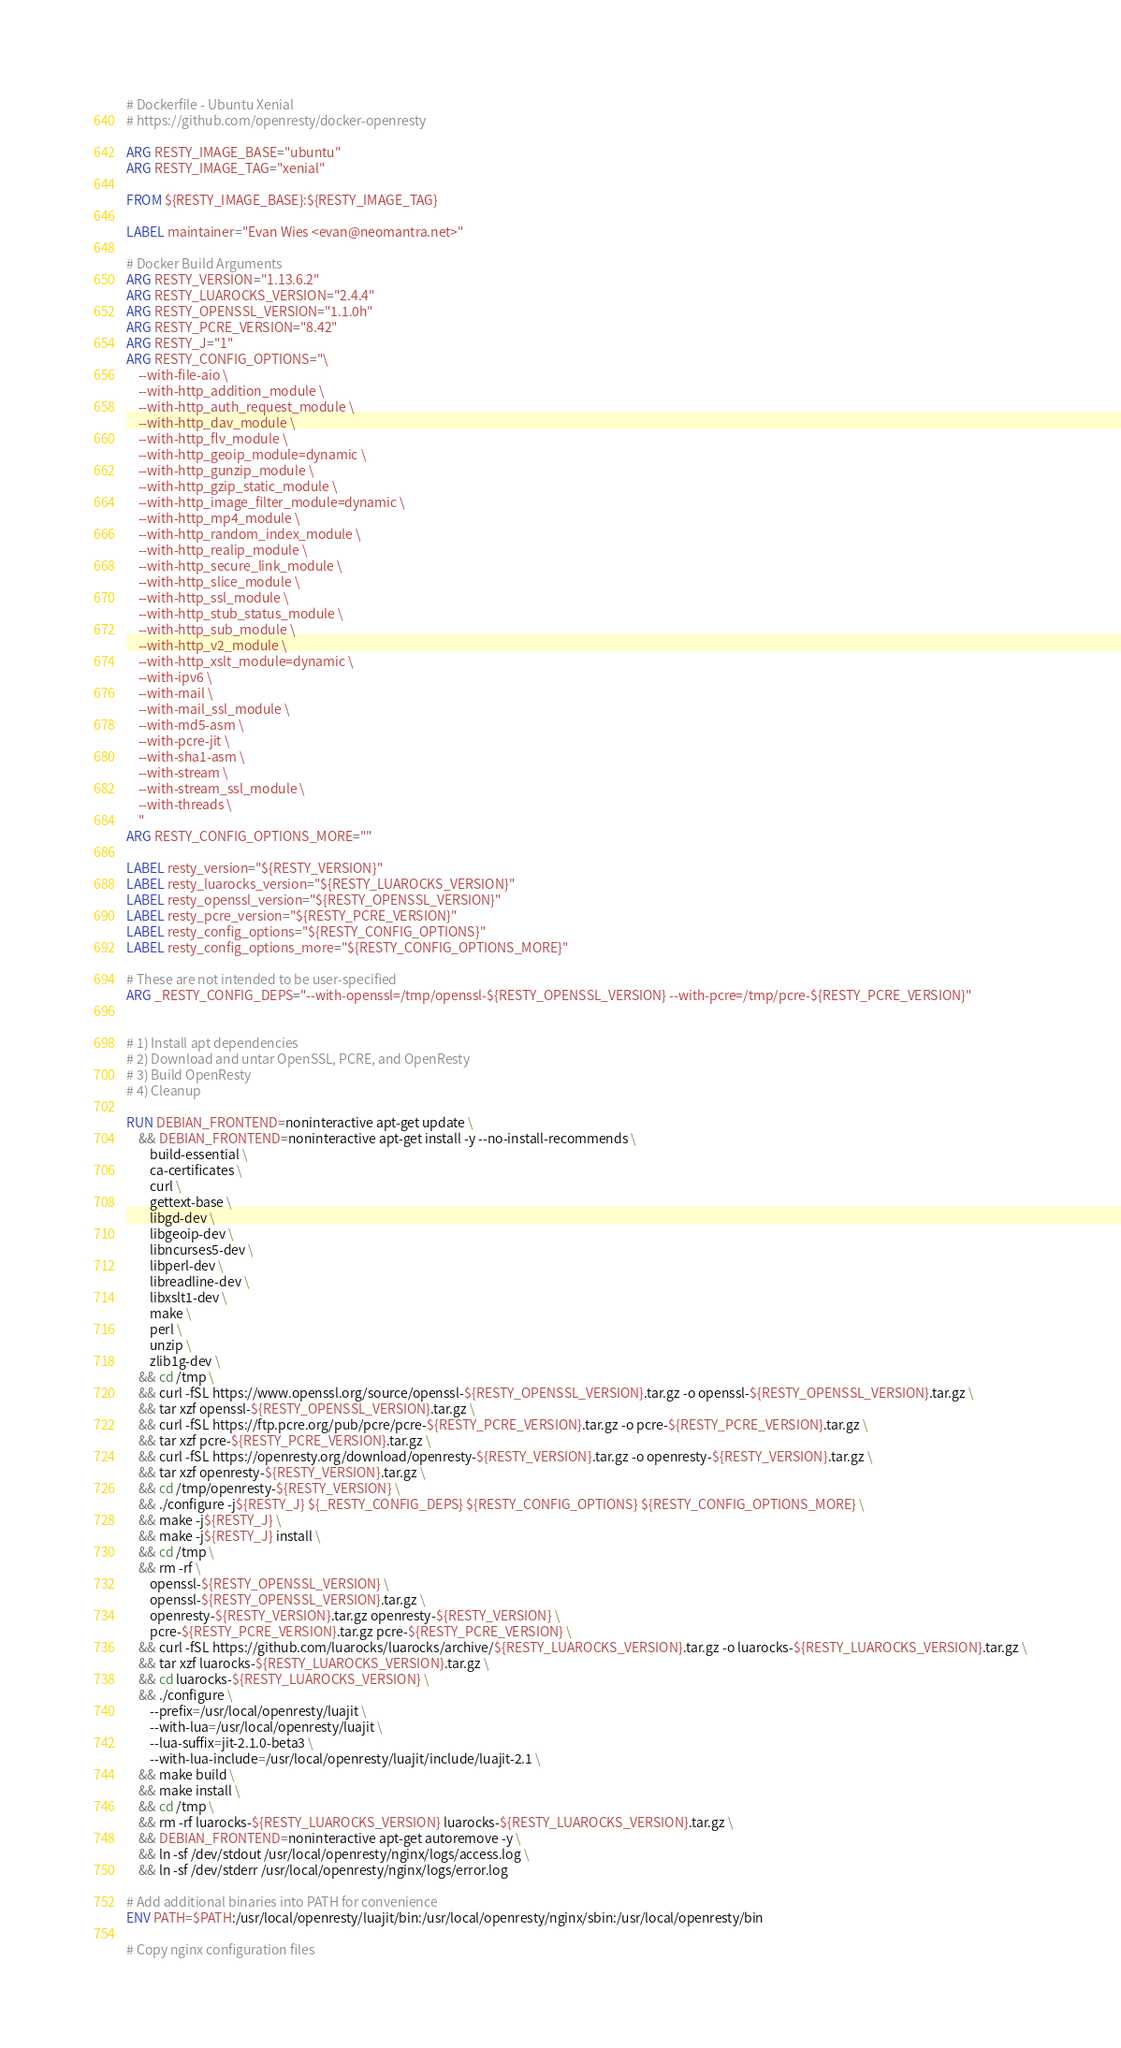<code> <loc_0><loc_0><loc_500><loc_500><_Dockerfile_># Dockerfile - Ubuntu Xenial
# https://github.com/openresty/docker-openresty

ARG RESTY_IMAGE_BASE="ubuntu"
ARG RESTY_IMAGE_TAG="xenial"

FROM ${RESTY_IMAGE_BASE}:${RESTY_IMAGE_TAG}

LABEL maintainer="Evan Wies <evan@neomantra.net>"

# Docker Build Arguments
ARG RESTY_VERSION="1.13.6.2"
ARG RESTY_LUAROCKS_VERSION="2.4.4"
ARG RESTY_OPENSSL_VERSION="1.1.0h"
ARG RESTY_PCRE_VERSION="8.42"
ARG RESTY_J="1"
ARG RESTY_CONFIG_OPTIONS="\
    --with-file-aio \
    --with-http_addition_module \
    --with-http_auth_request_module \
    --with-http_dav_module \
    --with-http_flv_module \
    --with-http_geoip_module=dynamic \
    --with-http_gunzip_module \
    --with-http_gzip_static_module \
    --with-http_image_filter_module=dynamic \
    --with-http_mp4_module \
    --with-http_random_index_module \
    --with-http_realip_module \
    --with-http_secure_link_module \
    --with-http_slice_module \
    --with-http_ssl_module \
    --with-http_stub_status_module \
    --with-http_sub_module \
    --with-http_v2_module \
    --with-http_xslt_module=dynamic \
    --with-ipv6 \
    --with-mail \
    --with-mail_ssl_module \
    --with-md5-asm \
    --with-pcre-jit \
    --with-sha1-asm \
    --with-stream \
    --with-stream_ssl_module \
    --with-threads \
    "
ARG RESTY_CONFIG_OPTIONS_MORE=""

LABEL resty_version="${RESTY_VERSION}"
LABEL resty_luarocks_version="${RESTY_LUAROCKS_VERSION}"
LABEL resty_openssl_version="${RESTY_OPENSSL_VERSION}"
LABEL resty_pcre_version="${RESTY_PCRE_VERSION}"
LABEL resty_config_options="${RESTY_CONFIG_OPTIONS}"
LABEL resty_config_options_more="${RESTY_CONFIG_OPTIONS_MORE}"

# These are not intended to be user-specified
ARG _RESTY_CONFIG_DEPS="--with-openssl=/tmp/openssl-${RESTY_OPENSSL_VERSION} --with-pcre=/tmp/pcre-${RESTY_PCRE_VERSION}"


# 1) Install apt dependencies
# 2) Download and untar OpenSSL, PCRE, and OpenResty
# 3) Build OpenResty
# 4) Cleanup

RUN DEBIAN_FRONTEND=noninteractive apt-get update \
    && DEBIAN_FRONTEND=noninteractive apt-get install -y --no-install-recommends \
        build-essential \
        ca-certificates \
        curl \
        gettext-base \
        libgd-dev \
        libgeoip-dev \
        libncurses5-dev \
        libperl-dev \
        libreadline-dev \
        libxslt1-dev \
        make \
        perl \
        unzip \
        zlib1g-dev \
    && cd /tmp \
    && curl -fSL https://www.openssl.org/source/openssl-${RESTY_OPENSSL_VERSION}.tar.gz -o openssl-${RESTY_OPENSSL_VERSION}.tar.gz \
    && tar xzf openssl-${RESTY_OPENSSL_VERSION}.tar.gz \
    && curl -fSL https://ftp.pcre.org/pub/pcre/pcre-${RESTY_PCRE_VERSION}.tar.gz -o pcre-${RESTY_PCRE_VERSION}.tar.gz \
    && tar xzf pcre-${RESTY_PCRE_VERSION}.tar.gz \
    && curl -fSL https://openresty.org/download/openresty-${RESTY_VERSION}.tar.gz -o openresty-${RESTY_VERSION}.tar.gz \
    && tar xzf openresty-${RESTY_VERSION}.tar.gz \
    && cd /tmp/openresty-${RESTY_VERSION} \
    && ./configure -j${RESTY_J} ${_RESTY_CONFIG_DEPS} ${RESTY_CONFIG_OPTIONS} ${RESTY_CONFIG_OPTIONS_MORE} \
    && make -j${RESTY_J} \
    && make -j${RESTY_J} install \
    && cd /tmp \
    && rm -rf \
        openssl-${RESTY_OPENSSL_VERSION} \
        openssl-${RESTY_OPENSSL_VERSION}.tar.gz \
        openresty-${RESTY_VERSION}.tar.gz openresty-${RESTY_VERSION} \
        pcre-${RESTY_PCRE_VERSION}.tar.gz pcre-${RESTY_PCRE_VERSION} \
    && curl -fSL https://github.com/luarocks/luarocks/archive/${RESTY_LUAROCKS_VERSION}.tar.gz -o luarocks-${RESTY_LUAROCKS_VERSION}.tar.gz \
    && tar xzf luarocks-${RESTY_LUAROCKS_VERSION}.tar.gz \
    && cd luarocks-${RESTY_LUAROCKS_VERSION} \
    && ./configure \
        --prefix=/usr/local/openresty/luajit \
        --with-lua=/usr/local/openresty/luajit \
        --lua-suffix=jit-2.1.0-beta3 \
        --with-lua-include=/usr/local/openresty/luajit/include/luajit-2.1 \
    && make build \
    && make install \
    && cd /tmp \
    && rm -rf luarocks-${RESTY_LUAROCKS_VERSION} luarocks-${RESTY_LUAROCKS_VERSION}.tar.gz \
    && DEBIAN_FRONTEND=noninteractive apt-get autoremove -y \
    && ln -sf /dev/stdout /usr/local/openresty/nginx/logs/access.log \
    && ln -sf /dev/stderr /usr/local/openresty/nginx/logs/error.log

# Add additional binaries into PATH for convenience
ENV PATH=$PATH:/usr/local/openresty/luajit/bin:/usr/local/openresty/nginx/sbin:/usr/local/openresty/bin

# Copy nginx configuration files</code> 